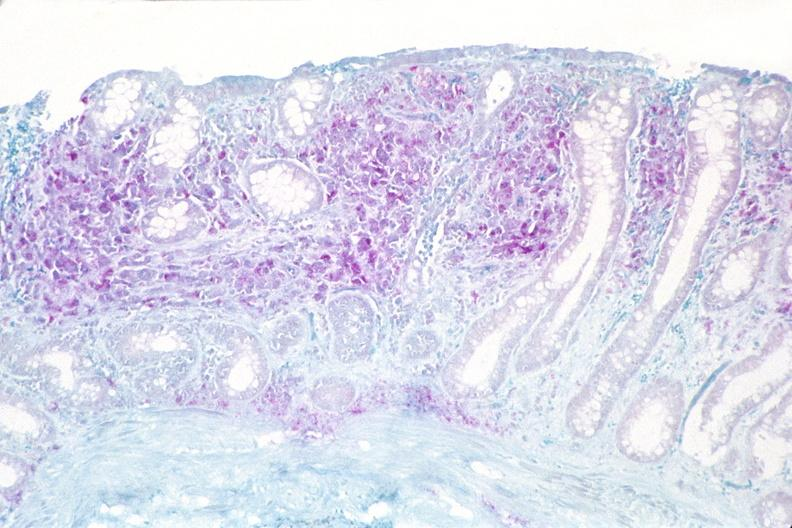what does this image show?
Answer the question using a single word or phrase. Colon biopsy 